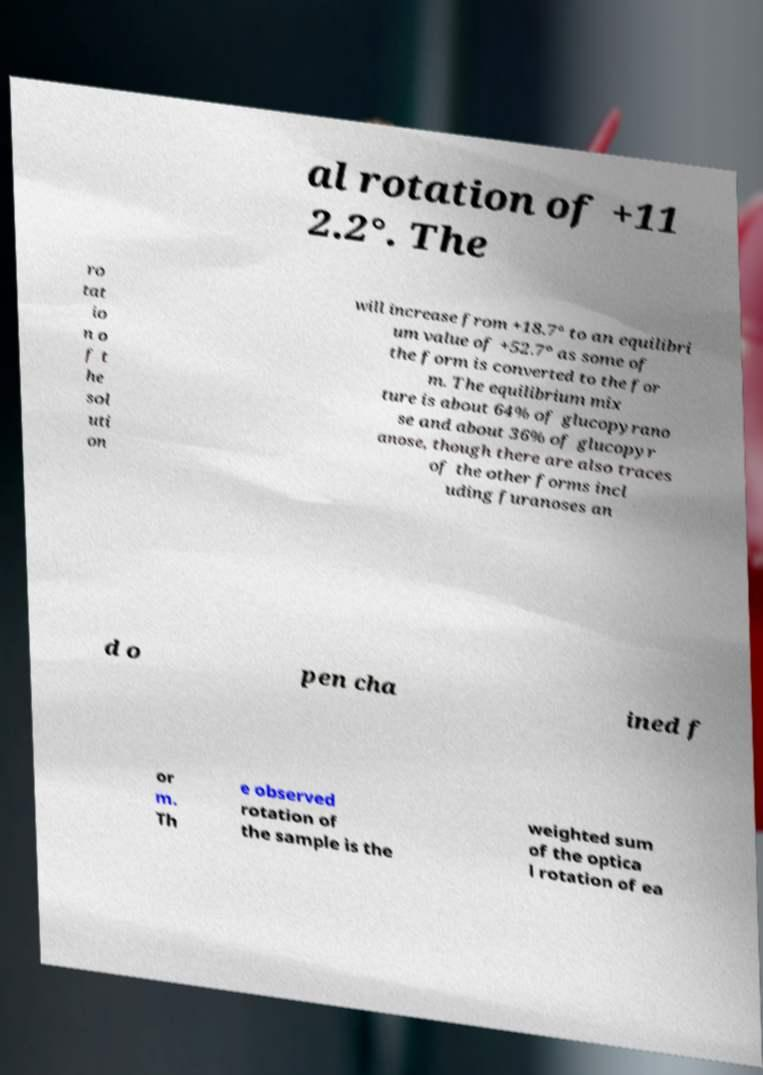Can you read and provide the text displayed in the image?This photo seems to have some interesting text. Can you extract and type it out for me? al rotation of +11 2.2°. The ro tat io n o f t he sol uti on will increase from +18.7° to an equilibri um value of +52.7° as some of the form is converted to the for m. The equilibrium mix ture is about 64% of glucopyrano se and about 36% of glucopyr anose, though there are also traces of the other forms incl uding furanoses an d o pen cha ined f or m. Th e observed rotation of the sample is the weighted sum of the optica l rotation of ea 